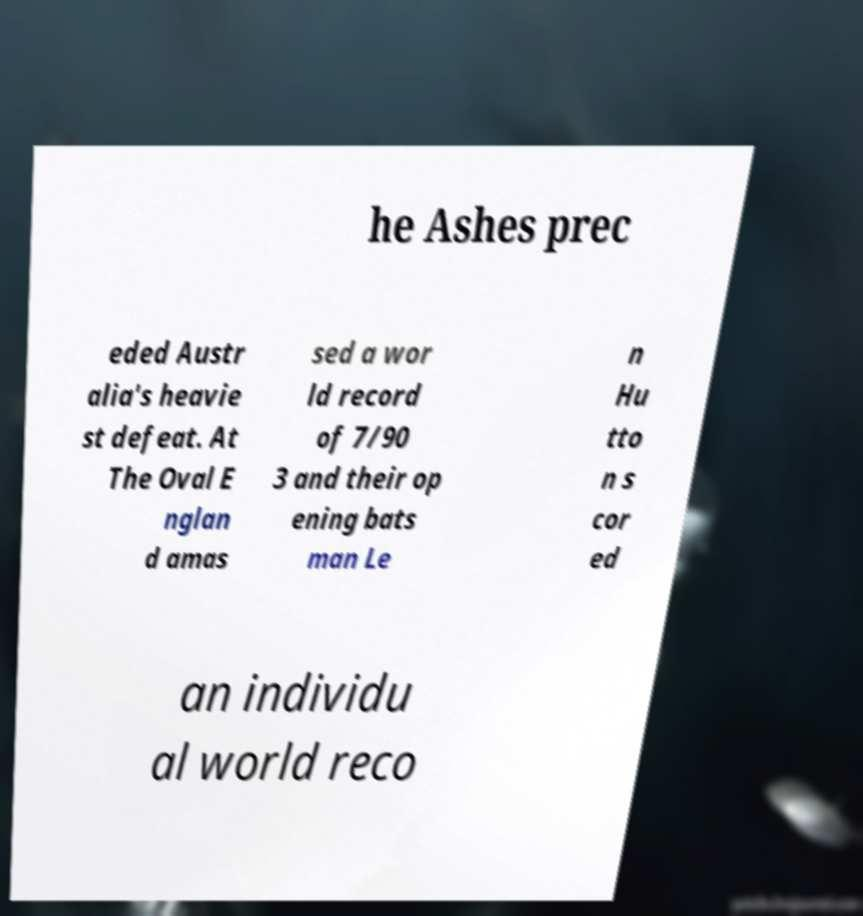Can you accurately transcribe the text from the provided image for me? he Ashes prec eded Austr alia's heavie st defeat. At The Oval E nglan d amas sed a wor ld record of 7/90 3 and their op ening bats man Le n Hu tto n s cor ed an individu al world reco 